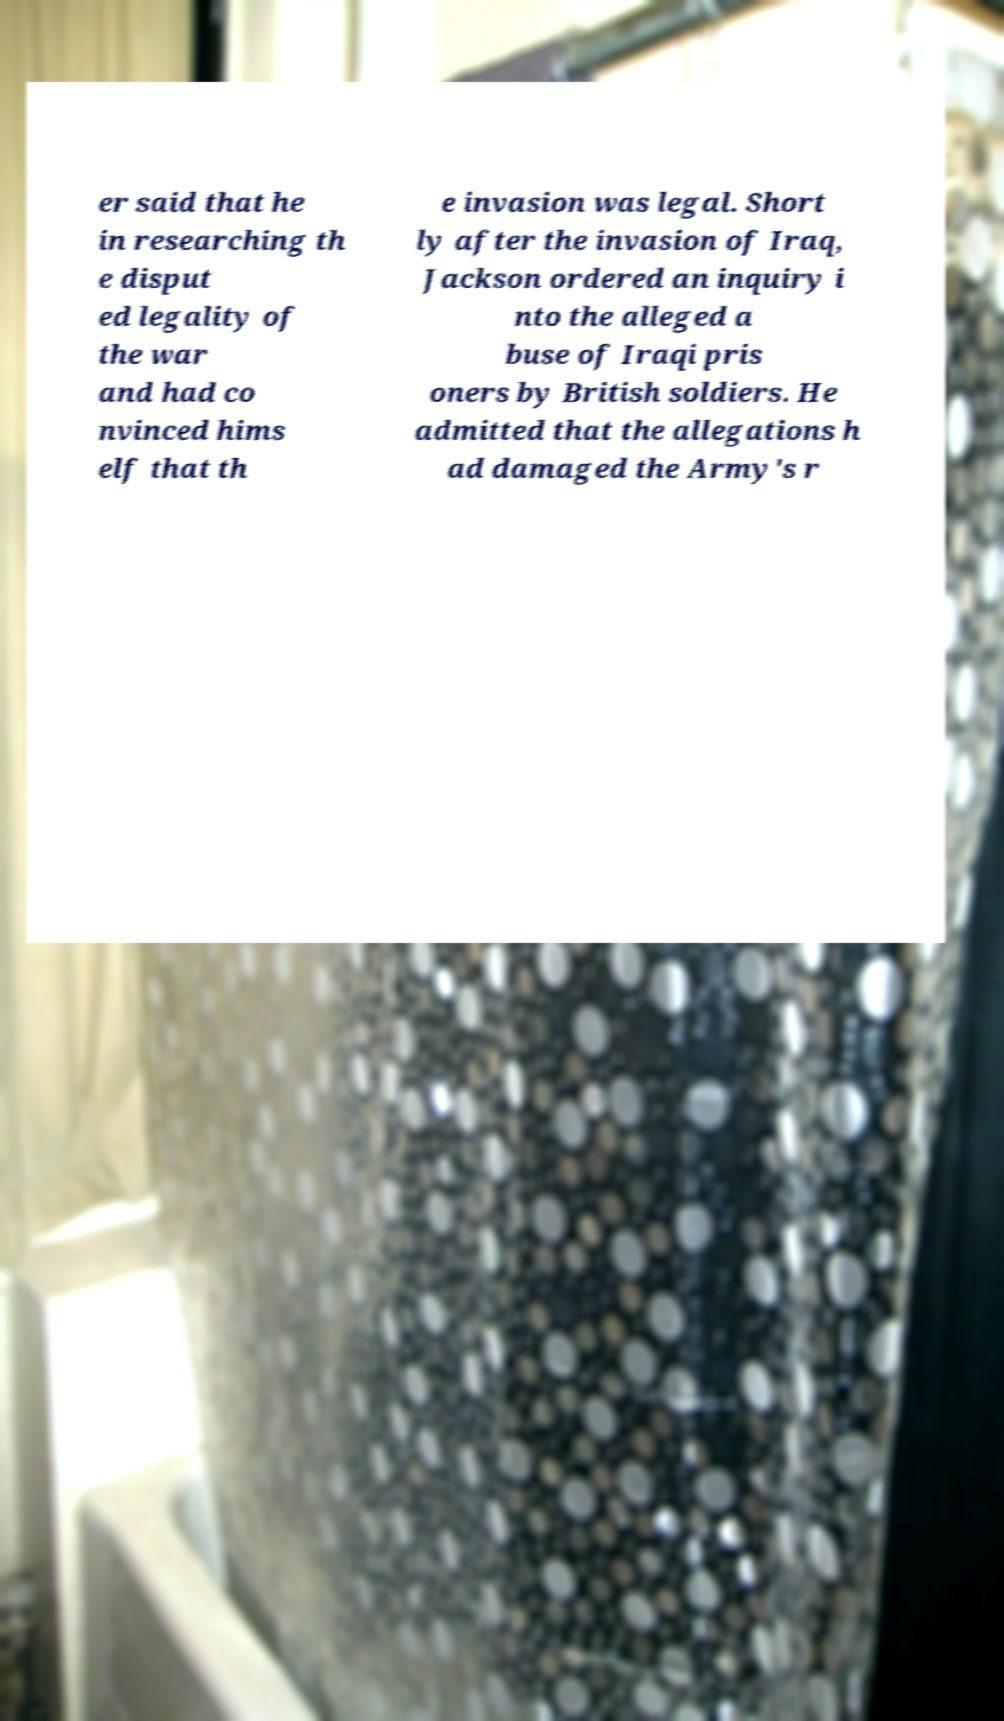Please read and relay the text visible in this image. What does it say? er said that he in researching th e disput ed legality of the war and had co nvinced hims elf that th e invasion was legal. Short ly after the invasion of Iraq, Jackson ordered an inquiry i nto the alleged a buse of Iraqi pris oners by British soldiers. He admitted that the allegations h ad damaged the Army's r 